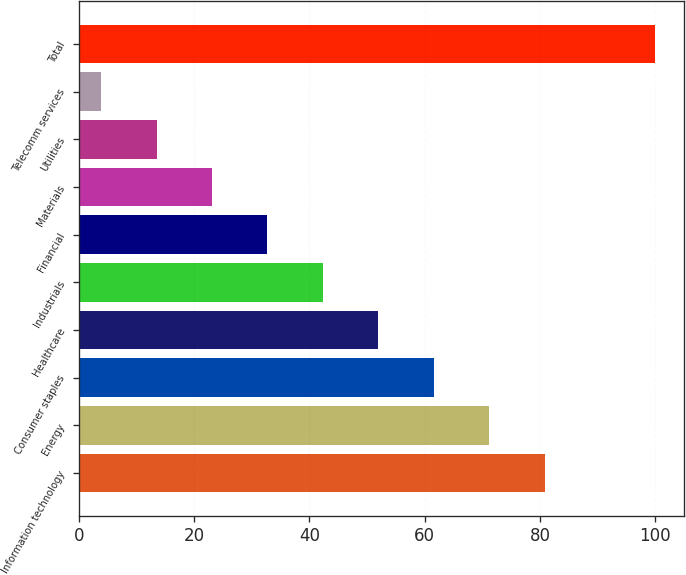Convert chart to OTSL. <chart><loc_0><loc_0><loc_500><loc_500><bar_chart><fcel>Information technology<fcel>Energy<fcel>Consumer staples<fcel>Healthcare<fcel>Industrials<fcel>Financial<fcel>Materials<fcel>Utilities<fcel>Telecomm services<fcel>Total<nl><fcel>80.78<fcel>71.17<fcel>61.56<fcel>51.95<fcel>42.34<fcel>32.73<fcel>23.12<fcel>13.51<fcel>3.9<fcel>100<nl></chart> 